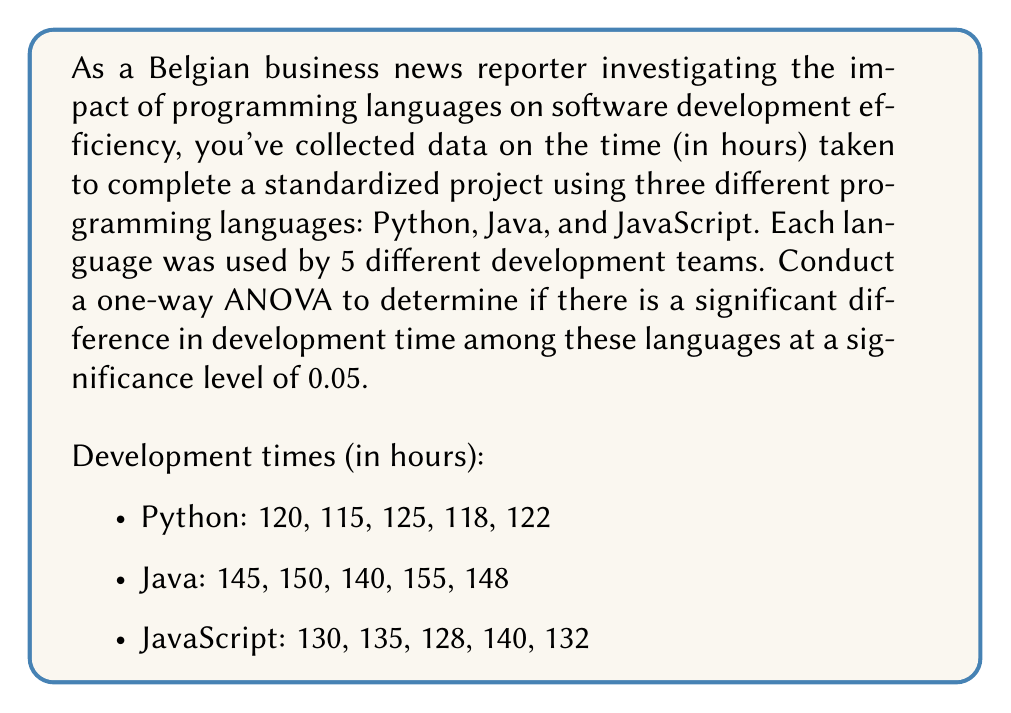Help me with this question. To conduct a one-way ANOVA, we'll follow these steps:

1. Calculate the sum of squares between groups (SSB), sum of squares within groups (SSW), and total sum of squares (SST).

2. Calculate the degrees of freedom for between groups (dfB), within groups (dfW), and total (dfT).

3. Calculate the mean square between groups (MSB) and mean square within groups (MSW).

4. Calculate the F-statistic.

5. Compare the F-statistic to the critical F-value.

Step 1: Calculate sum of squares

Grand mean: $\bar{X} = \frac{1903}{15} = 126.87$

SSB = $5[(120+115+125+118+122)/5 - 126.87]^2 + 5[(145+150+140+155+148)/5 - 126.87]^2 + 5[(130+135+128+140+132)/5 - 126.87]^2$
    = $5(-6.87)^2 + 5(20.13)^2 + 5(-3.27)^2$
    = $235.60 + 2026.07 + 53.46 = 2315.13$

SSW = $\sum_{i=1}^{3}\sum_{j=1}^{5}(X_{ij} - \bar{X_i})^2$
    = $[(120-120)^2 + (115-120)^2 + (125-120)^2 + (118-120)^2 + (122-120)^2]$
    + $[(145-147.6)^2 + (150-147.6)^2 + (140-147.6)^2 + (155-147.6)^2 + (148-147.6)^2]$
    + $[(130-133)^2 + (135-133)^2 + (128-133)^2 + (140-133)^2 + (132-133)^2]$
    = $70 + 142 + 116 = 328$

SST = SSB + SSW = 2315.13 + 328 = 2643.13

Step 2: Calculate degrees of freedom

dfB = 3 - 1 = 2
dfW = 15 - 3 = 12
dfT = 15 - 1 = 14

Step 3: Calculate mean squares

MSB = SSB / dfB = 2315.13 / 2 = 1157.57
MSW = SSW / dfW = 328 / 12 = 27.33

Step 4: Calculate F-statistic

F = MSB / MSW = 1157.57 / 27.33 = 42.35

Step 5: Compare F-statistic to critical F-value

The critical F-value for $F_{2,12}$ at α = 0.05 is approximately 3.89.

Since 42.35 > 3.89, we reject the null hypothesis.
Answer: The F-statistic (42.35) is greater than the critical F-value (3.89) at α = 0.05. Therefore, we reject the null hypothesis and conclude that there is a significant difference in development time among Python, Java, and JavaScript at the 0.05 significance level. 